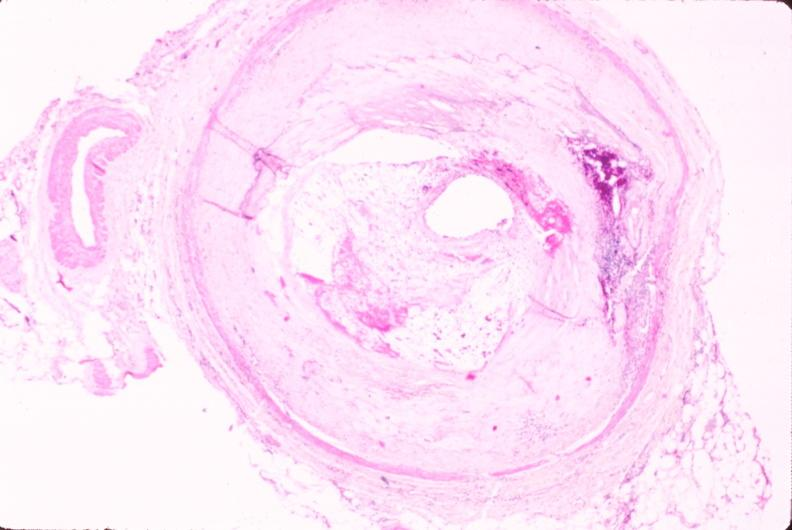what is present?
Answer the question using a single word or phrase. Cardiovascular 